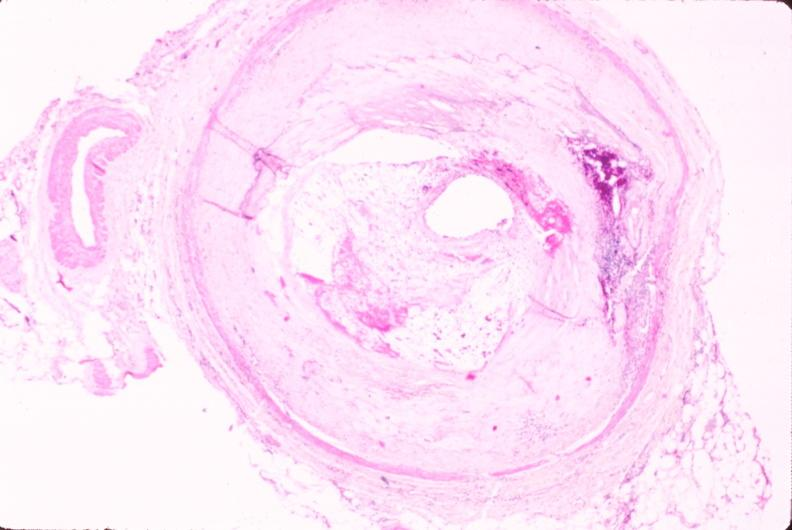what is present?
Answer the question using a single word or phrase. Cardiovascular 